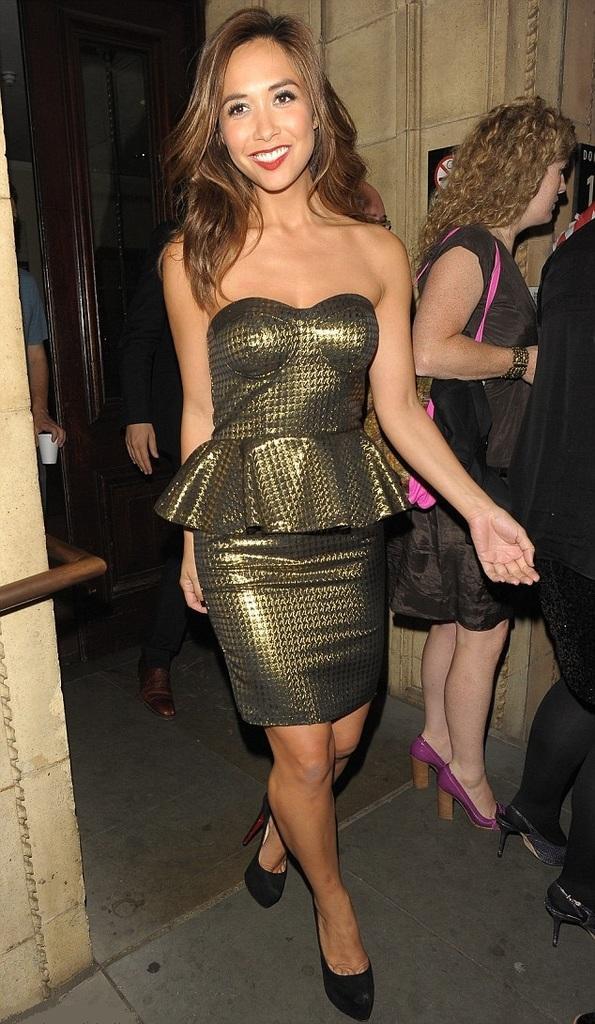Could you give a brief overview of what you see in this image? In this image, we can see two persons wearing clothes and standing beside the wall. There is an another persons in the middle of the image walking on the floor. There is a person hand on the left side of the image holding a cup. 